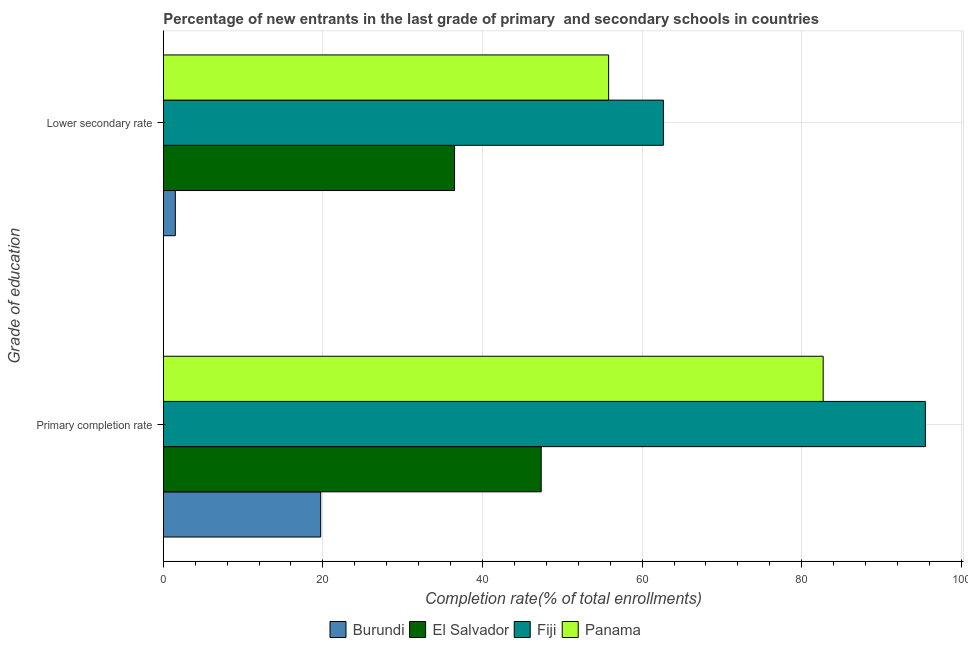How many different coloured bars are there?
Ensure brevity in your answer.  4. How many groups of bars are there?
Your answer should be very brief. 2. Are the number of bars per tick equal to the number of legend labels?
Keep it short and to the point. Yes. Are the number of bars on each tick of the Y-axis equal?
Your answer should be very brief. Yes. What is the label of the 2nd group of bars from the top?
Offer a terse response. Primary completion rate. What is the completion rate in primary schools in Panama?
Keep it short and to the point. 82.69. Across all countries, what is the maximum completion rate in secondary schools?
Your answer should be very brief. 62.66. Across all countries, what is the minimum completion rate in secondary schools?
Provide a short and direct response. 1.51. In which country was the completion rate in primary schools maximum?
Offer a very short reply. Fiji. In which country was the completion rate in primary schools minimum?
Keep it short and to the point. Burundi. What is the total completion rate in primary schools in the graph?
Your response must be concise. 245.26. What is the difference between the completion rate in primary schools in Panama and that in El Salvador?
Give a very brief answer. 35.33. What is the difference between the completion rate in secondary schools in Burundi and the completion rate in primary schools in Fiji?
Offer a terse response. -93.98. What is the average completion rate in secondary schools per country?
Offer a terse response. 39.12. What is the difference between the completion rate in primary schools and completion rate in secondary schools in Fiji?
Make the answer very short. 32.83. In how many countries, is the completion rate in primary schools greater than 4 %?
Make the answer very short. 4. What is the ratio of the completion rate in primary schools in Fiji to that in Burundi?
Give a very brief answer. 4.84. Is the completion rate in secondary schools in El Salvador less than that in Burundi?
Give a very brief answer. No. In how many countries, is the completion rate in primary schools greater than the average completion rate in primary schools taken over all countries?
Keep it short and to the point. 2. What does the 4th bar from the top in Lower secondary rate represents?
Keep it short and to the point. Burundi. What does the 2nd bar from the bottom in Primary completion rate represents?
Provide a short and direct response. El Salvador. How many bars are there?
Ensure brevity in your answer.  8. Does the graph contain any zero values?
Provide a succinct answer. No. Does the graph contain grids?
Provide a succinct answer. Yes. Where does the legend appear in the graph?
Make the answer very short. Bottom center. How many legend labels are there?
Keep it short and to the point. 4. How are the legend labels stacked?
Provide a succinct answer. Horizontal. What is the title of the graph?
Give a very brief answer. Percentage of new entrants in the last grade of primary  and secondary schools in countries. Does "Egypt, Arab Rep." appear as one of the legend labels in the graph?
Give a very brief answer. No. What is the label or title of the X-axis?
Give a very brief answer. Completion rate(% of total enrollments). What is the label or title of the Y-axis?
Provide a succinct answer. Grade of education. What is the Completion rate(% of total enrollments) in Burundi in Primary completion rate?
Keep it short and to the point. 19.72. What is the Completion rate(% of total enrollments) of El Salvador in Primary completion rate?
Offer a very short reply. 47.36. What is the Completion rate(% of total enrollments) of Fiji in Primary completion rate?
Your answer should be very brief. 95.49. What is the Completion rate(% of total enrollments) of Panama in Primary completion rate?
Provide a succinct answer. 82.69. What is the Completion rate(% of total enrollments) of Burundi in Lower secondary rate?
Make the answer very short. 1.51. What is the Completion rate(% of total enrollments) in El Salvador in Lower secondary rate?
Your answer should be compact. 36.5. What is the Completion rate(% of total enrollments) in Fiji in Lower secondary rate?
Keep it short and to the point. 62.66. What is the Completion rate(% of total enrollments) of Panama in Lower secondary rate?
Keep it short and to the point. 55.8. Across all Grade of education, what is the maximum Completion rate(% of total enrollments) in Burundi?
Keep it short and to the point. 19.72. Across all Grade of education, what is the maximum Completion rate(% of total enrollments) of El Salvador?
Ensure brevity in your answer.  47.36. Across all Grade of education, what is the maximum Completion rate(% of total enrollments) of Fiji?
Keep it short and to the point. 95.49. Across all Grade of education, what is the maximum Completion rate(% of total enrollments) in Panama?
Your answer should be very brief. 82.69. Across all Grade of education, what is the minimum Completion rate(% of total enrollments) of Burundi?
Your answer should be very brief. 1.51. Across all Grade of education, what is the minimum Completion rate(% of total enrollments) of El Salvador?
Give a very brief answer. 36.5. Across all Grade of education, what is the minimum Completion rate(% of total enrollments) of Fiji?
Offer a very short reply. 62.66. Across all Grade of education, what is the minimum Completion rate(% of total enrollments) of Panama?
Your response must be concise. 55.8. What is the total Completion rate(% of total enrollments) in Burundi in the graph?
Keep it short and to the point. 21.23. What is the total Completion rate(% of total enrollments) in El Salvador in the graph?
Provide a succinct answer. 83.85. What is the total Completion rate(% of total enrollments) in Fiji in the graph?
Your response must be concise. 158.15. What is the total Completion rate(% of total enrollments) of Panama in the graph?
Keep it short and to the point. 138.49. What is the difference between the Completion rate(% of total enrollments) of Burundi in Primary completion rate and that in Lower secondary rate?
Offer a very short reply. 18.21. What is the difference between the Completion rate(% of total enrollments) of El Salvador in Primary completion rate and that in Lower secondary rate?
Give a very brief answer. 10.86. What is the difference between the Completion rate(% of total enrollments) of Fiji in Primary completion rate and that in Lower secondary rate?
Make the answer very short. 32.83. What is the difference between the Completion rate(% of total enrollments) in Panama in Primary completion rate and that in Lower secondary rate?
Keep it short and to the point. 26.88. What is the difference between the Completion rate(% of total enrollments) of Burundi in Primary completion rate and the Completion rate(% of total enrollments) of El Salvador in Lower secondary rate?
Your response must be concise. -16.77. What is the difference between the Completion rate(% of total enrollments) of Burundi in Primary completion rate and the Completion rate(% of total enrollments) of Fiji in Lower secondary rate?
Provide a short and direct response. -42.94. What is the difference between the Completion rate(% of total enrollments) in Burundi in Primary completion rate and the Completion rate(% of total enrollments) in Panama in Lower secondary rate?
Make the answer very short. -36.08. What is the difference between the Completion rate(% of total enrollments) of El Salvador in Primary completion rate and the Completion rate(% of total enrollments) of Fiji in Lower secondary rate?
Offer a terse response. -15.31. What is the difference between the Completion rate(% of total enrollments) of El Salvador in Primary completion rate and the Completion rate(% of total enrollments) of Panama in Lower secondary rate?
Make the answer very short. -8.44. What is the difference between the Completion rate(% of total enrollments) of Fiji in Primary completion rate and the Completion rate(% of total enrollments) of Panama in Lower secondary rate?
Give a very brief answer. 39.69. What is the average Completion rate(% of total enrollments) in Burundi per Grade of education?
Provide a short and direct response. 10.62. What is the average Completion rate(% of total enrollments) of El Salvador per Grade of education?
Offer a very short reply. 41.93. What is the average Completion rate(% of total enrollments) of Fiji per Grade of education?
Your response must be concise. 79.08. What is the average Completion rate(% of total enrollments) of Panama per Grade of education?
Make the answer very short. 69.24. What is the difference between the Completion rate(% of total enrollments) in Burundi and Completion rate(% of total enrollments) in El Salvador in Primary completion rate?
Offer a terse response. -27.63. What is the difference between the Completion rate(% of total enrollments) in Burundi and Completion rate(% of total enrollments) in Fiji in Primary completion rate?
Provide a succinct answer. -75.77. What is the difference between the Completion rate(% of total enrollments) in Burundi and Completion rate(% of total enrollments) in Panama in Primary completion rate?
Give a very brief answer. -62.96. What is the difference between the Completion rate(% of total enrollments) in El Salvador and Completion rate(% of total enrollments) in Fiji in Primary completion rate?
Make the answer very short. -48.13. What is the difference between the Completion rate(% of total enrollments) in El Salvador and Completion rate(% of total enrollments) in Panama in Primary completion rate?
Give a very brief answer. -35.33. What is the difference between the Completion rate(% of total enrollments) of Fiji and Completion rate(% of total enrollments) of Panama in Primary completion rate?
Your answer should be compact. 12.81. What is the difference between the Completion rate(% of total enrollments) in Burundi and Completion rate(% of total enrollments) in El Salvador in Lower secondary rate?
Offer a terse response. -34.99. What is the difference between the Completion rate(% of total enrollments) in Burundi and Completion rate(% of total enrollments) in Fiji in Lower secondary rate?
Give a very brief answer. -61.15. What is the difference between the Completion rate(% of total enrollments) in Burundi and Completion rate(% of total enrollments) in Panama in Lower secondary rate?
Your response must be concise. -54.29. What is the difference between the Completion rate(% of total enrollments) of El Salvador and Completion rate(% of total enrollments) of Fiji in Lower secondary rate?
Offer a terse response. -26.17. What is the difference between the Completion rate(% of total enrollments) in El Salvador and Completion rate(% of total enrollments) in Panama in Lower secondary rate?
Your answer should be very brief. -19.3. What is the difference between the Completion rate(% of total enrollments) of Fiji and Completion rate(% of total enrollments) of Panama in Lower secondary rate?
Provide a succinct answer. 6.86. What is the ratio of the Completion rate(% of total enrollments) in Burundi in Primary completion rate to that in Lower secondary rate?
Your response must be concise. 13.06. What is the ratio of the Completion rate(% of total enrollments) in El Salvador in Primary completion rate to that in Lower secondary rate?
Provide a short and direct response. 1.3. What is the ratio of the Completion rate(% of total enrollments) in Fiji in Primary completion rate to that in Lower secondary rate?
Ensure brevity in your answer.  1.52. What is the ratio of the Completion rate(% of total enrollments) in Panama in Primary completion rate to that in Lower secondary rate?
Your response must be concise. 1.48. What is the difference between the highest and the second highest Completion rate(% of total enrollments) of Burundi?
Your response must be concise. 18.21. What is the difference between the highest and the second highest Completion rate(% of total enrollments) of El Salvador?
Your answer should be compact. 10.86. What is the difference between the highest and the second highest Completion rate(% of total enrollments) of Fiji?
Provide a short and direct response. 32.83. What is the difference between the highest and the second highest Completion rate(% of total enrollments) in Panama?
Your response must be concise. 26.88. What is the difference between the highest and the lowest Completion rate(% of total enrollments) in Burundi?
Provide a short and direct response. 18.21. What is the difference between the highest and the lowest Completion rate(% of total enrollments) in El Salvador?
Ensure brevity in your answer.  10.86. What is the difference between the highest and the lowest Completion rate(% of total enrollments) in Fiji?
Your answer should be compact. 32.83. What is the difference between the highest and the lowest Completion rate(% of total enrollments) in Panama?
Make the answer very short. 26.88. 